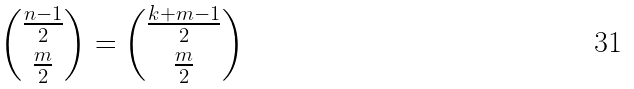Convert formula to latex. <formula><loc_0><loc_0><loc_500><loc_500>{ \frac { n - 1 } { 2 } \choose \frac { m } { 2 } } = { \frac { k + m - 1 } { 2 } \choose \frac { m } { 2 } }</formula> 